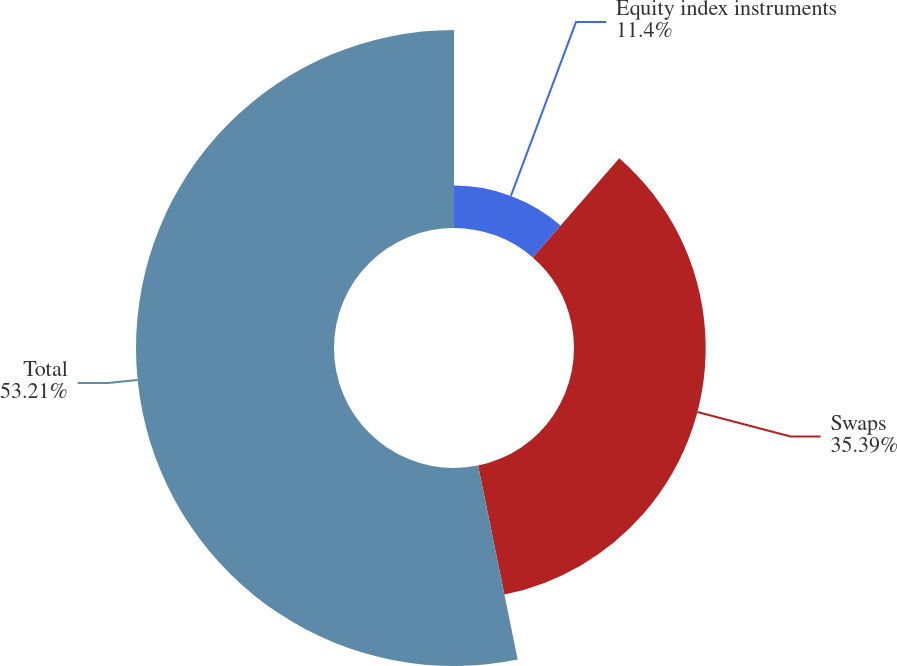Convert chart to OTSL. <chart><loc_0><loc_0><loc_500><loc_500><pie_chart><fcel>Equity index instruments<fcel>Swaps<fcel>Total<nl><fcel>11.4%<fcel>35.39%<fcel>53.21%<nl></chart> 